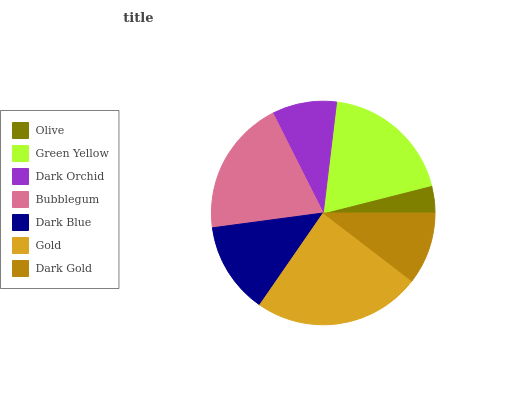Is Olive the minimum?
Answer yes or no. Yes. Is Gold the maximum?
Answer yes or no. Yes. Is Green Yellow the minimum?
Answer yes or no. No. Is Green Yellow the maximum?
Answer yes or no. No. Is Green Yellow greater than Olive?
Answer yes or no. Yes. Is Olive less than Green Yellow?
Answer yes or no. Yes. Is Olive greater than Green Yellow?
Answer yes or no. No. Is Green Yellow less than Olive?
Answer yes or no. No. Is Dark Blue the high median?
Answer yes or no. Yes. Is Dark Blue the low median?
Answer yes or no. Yes. Is Dark Gold the high median?
Answer yes or no. No. Is Dark Orchid the low median?
Answer yes or no. No. 